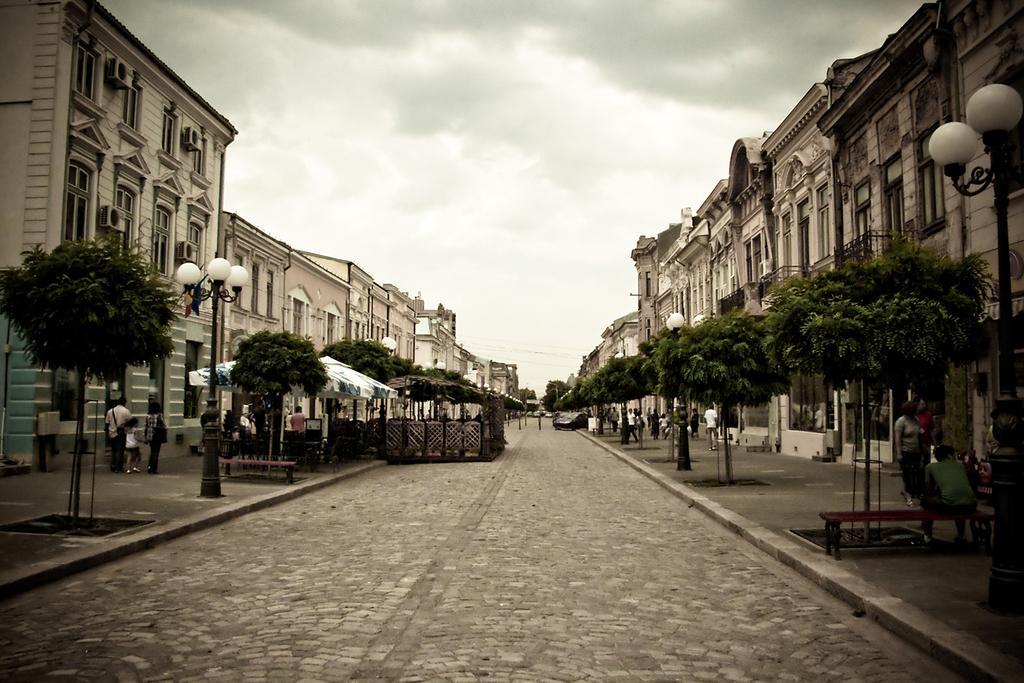In one or two sentences, can you explain what this image depicts? In this picture we can see a group of people where some are sitting and some are walking on footpaths, buildings with windows, trees, car on the road and in the background we can see the sky with clouds. 